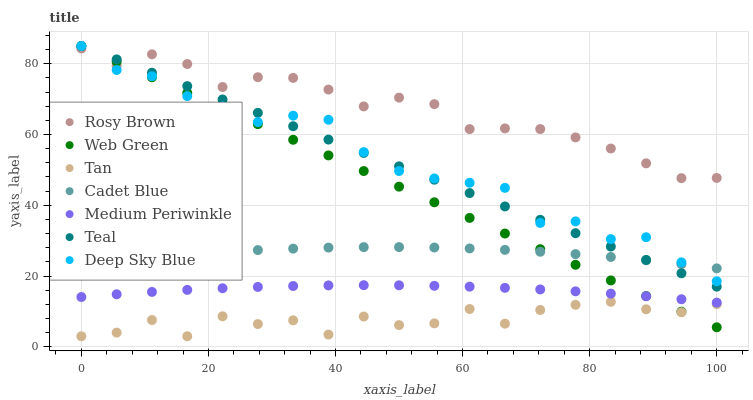Does Tan have the minimum area under the curve?
Answer yes or no. Yes. Does Rosy Brown have the maximum area under the curve?
Answer yes or no. Yes. Does Deep Sky Blue have the minimum area under the curve?
Answer yes or no. No. Does Deep Sky Blue have the maximum area under the curve?
Answer yes or no. No. Is Teal the smoothest?
Answer yes or no. Yes. Is Tan the roughest?
Answer yes or no. Yes. Is Deep Sky Blue the smoothest?
Answer yes or no. No. Is Deep Sky Blue the roughest?
Answer yes or no. No. Does Tan have the lowest value?
Answer yes or no. Yes. Does Deep Sky Blue have the lowest value?
Answer yes or no. No. Does Teal have the highest value?
Answer yes or no. Yes. Does Rosy Brown have the highest value?
Answer yes or no. No. Is Medium Periwinkle less than Teal?
Answer yes or no. Yes. Is Rosy Brown greater than Medium Periwinkle?
Answer yes or no. Yes. Does Teal intersect Web Green?
Answer yes or no. Yes. Is Teal less than Web Green?
Answer yes or no. No. Is Teal greater than Web Green?
Answer yes or no. No. Does Medium Periwinkle intersect Teal?
Answer yes or no. No. 